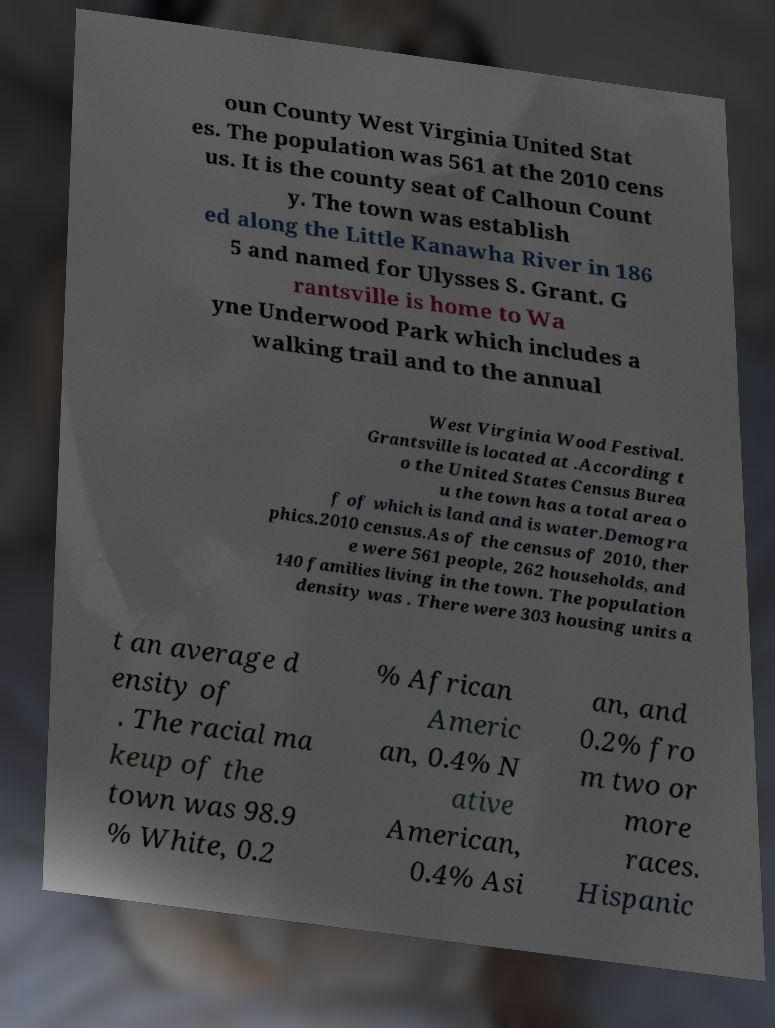Please identify and transcribe the text found in this image. oun County West Virginia United Stat es. The population was 561 at the 2010 cens us. It is the county seat of Calhoun Count y. The town was establish ed along the Little Kanawha River in 186 5 and named for Ulysses S. Grant. G rantsville is home to Wa yne Underwood Park which includes a walking trail and to the annual West Virginia Wood Festival. Grantsville is located at .According t o the United States Census Burea u the town has a total area o f of which is land and is water.Demogra phics.2010 census.As of the census of 2010, ther e were 561 people, 262 households, and 140 families living in the town. The population density was . There were 303 housing units a t an average d ensity of . The racial ma keup of the town was 98.9 % White, 0.2 % African Americ an, 0.4% N ative American, 0.4% Asi an, and 0.2% fro m two or more races. Hispanic 